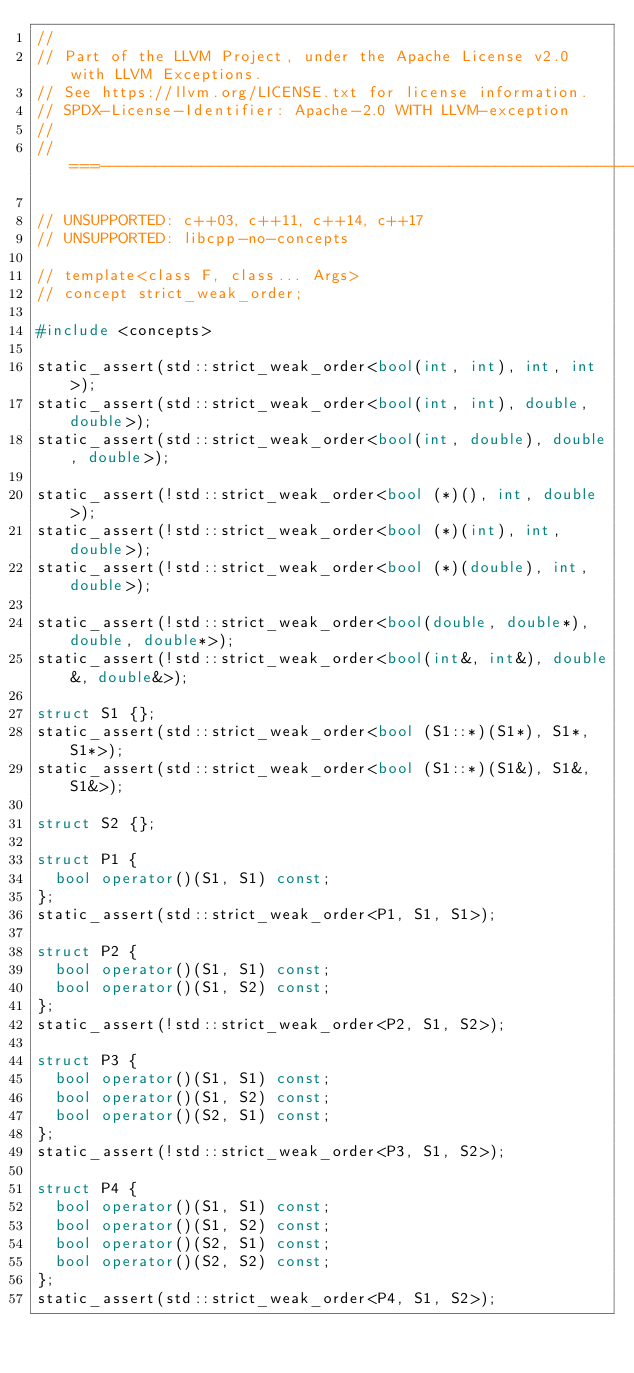<code> <loc_0><loc_0><loc_500><loc_500><_C++_>//
// Part of the LLVM Project, under the Apache License v2.0 with LLVM Exceptions.
// See https://llvm.org/LICENSE.txt for license information.
// SPDX-License-Identifier: Apache-2.0 WITH LLVM-exception
//
//===----------------------------------------------------------------------===//

// UNSUPPORTED: c++03, c++11, c++14, c++17
// UNSUPPORTED: libcpp-no-concepts

// template<class F, class... Args>
// concept strict_weak_order;

#include <concepts>

static_assert(std::strict_weak_order<bool(int, int), int, int>);
static_assert(std::strict_weak_order<bool(int, int), double, double>);
static_assert(std::strict_weak_order<bool(int, double), double, double>);

static_assert(!std::strict_weak_order<bool (*)(), int, double>);
static_assert(!std::strict_weak_order<bool (*)(int), int, double>);
static_assert(!std::strict_weak_order<bool (*)(double), int, double>);

static_assert(!std::strict_weak_order<bool(double, double*), double, double*>);
static_assert(!std::strict_weak_order<bool(int&, int&), double&, double&>);

struct S1 {};
static_assert(std::strict_weak_order<bool (S1::*)(S1*), S1*, S1*>);
static_assert(std::strict_weak_order<bool (S1::*)(S1&), S1&, S1&>);

struct S2 {};

struct P1 {
  bool operator()(S1, S1) const;
};
static_assert(std::strict_weak_order<P1, S1, S1>);

struct P2 {
  bool operator()(S1, S1) const;
  bool operator()(S1, S2) const;
};
static_assert(!std::strict_weak_order<P2, S1, S2>);

struct P3 {
  bool operator()(S1, S1) const;
  bool operator()(S1, S2) const;
  bool operator()(S2, S1) const;
};
static_assert(!std::strict_weak_order<P3, S1, S2>);

struct P4 {
  bool operator()(S1, S1) const;
  bool operator()(S1, S2) const;
  bool operator()(S2, S1) const;
  bool operator()(S2, S2) const;
};
static_assert(std::strict_weak_order<P4, S1, S2>);
</code> 